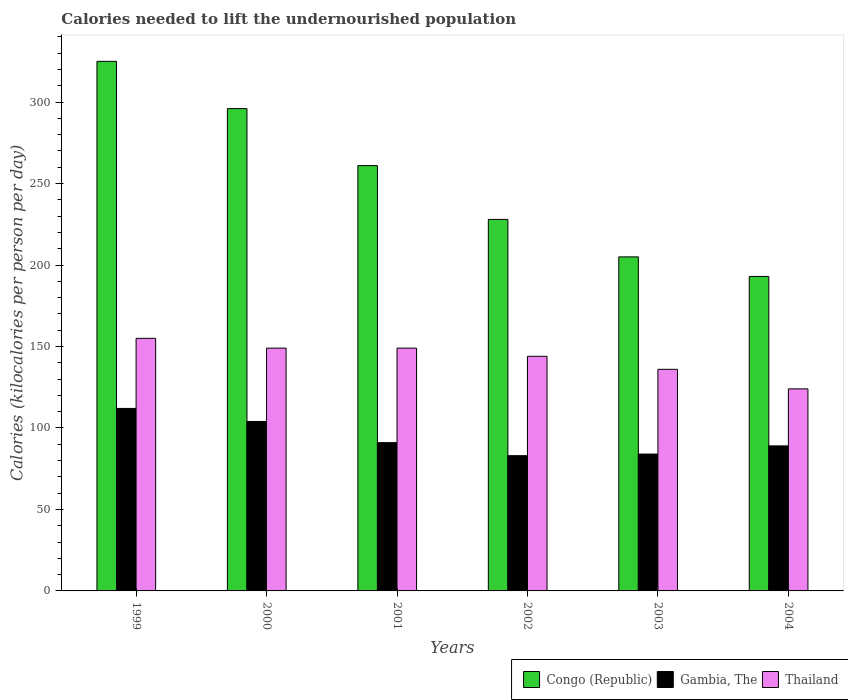How many groups of bars are there?
Make the answer very short. 6. Are the number of bars on each tick of the X-axis equal?
Offer a terse response. Yes. What is the total calories needed to lift the undernourished population in Gambia, The in 2003?
Make the answer very short. 84. Across all years, what is the maximum total calories needed to lift the undernourished population in Congo (Republic)?
Ensure brevity in your answer.  325. Across all years, what is the minimum total calories needed to lift the undernourished population in Congo (Republic)?
Your response must be concise. 193. In which year was the total calories needed to lift the undernourished population in Congo (Republic) maximum?
Offer a terse response. 1999. In which year was the total calories needed to lift the undernourished population in Congo (Republic) minimum?
Offer a terse response. 2004. What is the total total calories needed to lift the undernourished population in Thailand in the graph?
Provide a short and direct response. 857. What is the difference between the total calories needed to lift the undernourished population in Gambia, The in 2000 and that in 2004?
Your response must be concise. 15. What is the difference between the total calories needed to lift the undernourished population in Congo (Republic) in 2000 and the total calories needed to lift the undernourished population in Thailand in 2001?
Provide a short and direct response. 147. What is the average total calories needed to lift the undernourished population in Gambia, The per year?
Offer a terse response. 93.83. In the year 2004, what is the difference between the total calories needed to lift the undernourished population in Thailand and total calories needed to lift the undernourished population in Congo (Republic)?
Offer a terse response. -69. What is the ratio of the total calories needed to lift the undernourished population in Congo (Republic) in 2003 to that in 2004?
Keep it short and to the point. 1.06. Is the total calories needed to lift the undernourished population in Gambia, The in 1999 less than that in 2000?
Your response must be concise. No. Is the difference between the total calories needed to lift the undernourished population in Thailand in 1999 and 2000 greater than the difference between the total calories needed to lift the undernourished population in Congo (Republic) in 1999 and 2000?
Offer a very short reply. No. What is the difference between the highest and the second highest total calories needed to lift the undernourished population in Congo (Republic)?
Provide a short and direct response. 29. What is the difference between the highest and the lowest total calories needed to lift the undernourished population in Congo (Republic)?
Provide a short and direct response. 132. Is the sum of the total calories needed to lift the undernourished population in Congo (Republic) in 1999 and 2004 greater than the maximum total calories needed to lift the undernourished population in Thailand across all years?
Give a very brief answer. Yes. What does the 1st bar from the left in 2001 represents?
Give a very brief answer. Congo (Republic). What does the 2nd bar from the right in 2000 represents?
Keep it short and to the point. Gambia, The. Is it the case that in every year, the sum of the total calories needed to lift the undernourished population in Thailand and total calories needed to lift the undernourished population in Congo (Republic) is greater than the total calories needed to lift the undernourished population in Gambia, The?
Offer a very short reply. Yes. How many bars are there?
Make the answer very short. 18. How many years are there in the graph?
Provide a short and direct response. 6. What is the difference between two consecutive major ticks on the Y-axis?
Give a very brief answer. 50. Does the graph contain any zero values?
Offer a very short reply. No. Does the graph contain grids?
Ensure brevity in your answer.  No. How many legend labels are there?
Offer a terse response. 3. What is the title of the graph?
Your response must be concise. Calories needed to lift the undernourished population. Does "Sao Tome and Principe" appear as one of the legend labels in the graph?
Offer a very short reply. No. What is the label or title of the X-axis?
Your response must be concise. Years. What is the label or title of the Y-axis?
Provide a short and direct response. Calories (kilocalories per person per day). What is the Calories (kilocalories per person per day) in Congo (Republic) in 1999?
Provide a short and direct response. 325. What is the Calories (kilocalories per person per day) in Gambia, The in 1999?
Offer a very short reply. 112. What is the Calories (kilocalories per person per day) of Thailand in 1999?
Make the answer very short. 155. What is the Calories (kilocalories per person per day) in Congo (Republic) in 2000?
Give a very brief answer. 296. What is the Calories (kilocalories per person per day) in Gambia, The in 2000?
Give a very brief answer. 104. What is the Calories (kilocalories per person per day) in Thailand in 2000?
Provide a succinct answer. 149. What is the Calories (kilocalories per person per day) of Congo (Republic) in 2001?
Provide a succinct answer. 261. What is the Calories (kilocalories per person per day) of Gambia, The in 2001?
Give a very brief answer. 91. What is the Calories (kilocalories per person per day) of Thailand in 2001?
Offer a very short reply. 149. What is the Calories (kilocalories per person per day) in Congo (Republic) in 2002?
Provide a succinct answer. 228. What is the Calories (kilocalories per person per day) in Thailand in 2002?
Ensure brevity in your answer.  144. What is the Calories (kilocalories per person per day) in Congo (Republic) in 2003?
Offer a very short reply. 205. What is the Calories (kilocalories per person per day) of Gambia, The in 2003?
Your answer should be very brief. 84. What is the Calories (kilocalories per person per day) in Thailand in 2003?
Make the answer very short. 136. What is the Calories (kilocalories per person per day) of Congo (Republic) in 2004?
Give a very brief answer. 193. What is the Calories (kilocalories per person per day) of Gambia, The in 2004?
Provide a short and direct response. 89. What is the Calories (kilocalories per person per day) of Thailand in 2004?
Your answer should be very brief. 124. Across all years, what is the maximum Calories (kilocalories per person per day) of Congo (Republic)?
Keep it short and to the point. 325. Across all years, what is the maximum Calories (kilocalories per person per day) of Gambia, The?
Provide a succinct answer. 112. Across all years, what is the maximum Calories (kilocalories per person per day) of Thailand?
Keep it short and to the point. 155. Across all years, what is the minimum Calories (kilocalories per person per day) in Congo (Republic)?
Provide a succinct answer. 193. Across all years, what is the minimum Calories (kilocalories per person per day) in Gambia, The?
Offer a terse response. 83. Across all years, what is the minimum Calories (kilocalories per person per day) in Thailand?
Your answer should be compact. 124. What is the total Calories (kilocalories per person per day) of Congo (Republic) in the graph?
Your answer should be compact. 1508. What is the total Calories (kilocalories per person per day) in Gambia, The in the graph?
Make the answer very short. 563. What is the total Calories (kilocalories per person per day) of Thailand in the graph?
Keep it short and to the point. 857. What is the difference between the Calories (kilocalories per person per day) of Gambia, The in 1999 and that in 2000?
Provide a succinct answer. 8. What is the difference between the Calories (kilocalories per person per day) in Gambia, The in 1999 and that in 2001?
Make the answer very short. 21. What is the difference between the Calories (kilocalories per person per day) of Thailand in 1999 and that in 2001?
Ensure brevity in your answer.  6. What is the difference between the Calories (kilocalories per person per day) of Congo (Republic) in 1999 and that in 2002?
Offer a very short reply. 97. What is the difference between the Calories (kilocalories per person per day) in Congo (Republic) in 1999 and that in 2003?
Give a very brief answer. 120. What is the difference between the Calories (kilocalories per person per day) in Congo (Republic) in 1999 and that in 2004?
Ensure brevity in your answer.  132. What is the difference between the Calories (kilocalories per person per day) in Gambia, The in 1999 and that in 2004?
Make the answer very short. 23. What is the difference between the Calories (kilocalories per person per day) in Thailand in 2000 and that in 2002?
Offer a terse response. 5. What is the difference between the Calories (kilocalories per person per day) of Congo (Republic) in 2000 and that in 2003?
Give a very brief answer. 91. What is the difference between the Calories (kilocalories per person per day) of Thailand in 2000 and that in 2003?
Provide a succinct answer. 13. What is the difference between the Calories (kilocalories per person per day) in Congo (Republic) in 2000 and that in 2004?
Your response must be concise. 103. What is the difference between the Calories (kilocalories per person per day) in Gambia, The in 2000 and that in 2004?
Ensure brevity in your answer.  15. What is the difference between the Calories (kilocalories per person per day) in Thailand in 2000 and that in 2004?
Ensure brevity in your answer.  25. What is the difference between the Calories (kilocalories per person per day) in Thailand in 2001 and that in 2002?
Ensure brevity in your answer.  5. What is the difference between the Calories (kilocalories per person per day) of Congo (Republic) in 2001 and that in 2003?
Offer a terse response. 56. What is the difference between the Calories (kilocalories per person per day) of Gambia, The in 2001 and that in 2003?
Offer a terse response. 7. What is the difference between the Calories (kilocalories per person per day) of Thailand in 2001 and that in 2004?
Offer a very short reply. 25. What is the difference between the Calories (kilocalories per person per day) of Congo (Republic) in 2002 and that in 2003?
Ensure brevity in your answer.  23. What is the difference between the Calories (kilocalories per person per day) of Gambia, The in 2002 and that in 2003?
Provide a succinct answer. -1. What is the difference between the Calories (kilocalories per person per day) of Thailand in 2002 and that in 2003?
Provide a succinct answer. 8. What is the difference between the Calories (kilocalories per person per day) of Gambia, The in 2003 and that in 2004?
Your response must be concise. -5. What is the difference between the Calories (kilocalories per person per day) in Thailand in 2003 and that in 2004?
Provide a short and direct response. 12. What is the difference between the Calories (kilocalories per person per day) of Congo (Republic) in 1999 and the Calories (kilocalories per person per day) of Gambia, The in 2000?
Ensure brevity in your answer.  221. What is the difference between the Calories (kilocalories per person per day) in Congo (Republic) in 1999 and the Calories (kilocalories per person per day) in Thailand in 2000?
Provide a succinct answer. 176. What is the difference between the Calories (kilocalories per person per day) in Gambia, The in 1999 and the Calories (kilocalories per person per day) in Thailand in 2000?
Provide a succinct answer. -37. What is the difference between the Calories (kilocalories per person per day) of Congo (Republic) in 1999 and the Calories (kilocalories per person per day) of Gambia, The in 2001?
Ensure brevity in your answer.  234. What is the difference between the Calories (kilocalories per person per day) in Congo (Republic) in 1999 and the Calories (kilocalories per person per day) in Thailand in 2001?
Your answer should be very brief. 176. What is the difference between the Calories (kilocalories per person per day) in Gambia, The in 1999 and the Calories (kilocalories per person per day) in Thailand in 2001?
Ensure brevity in your answer.  -37. What is the difference between the Calories (kilocalories per person per day) of Congo (Republic) in 1999 and the Calories (kilocalories per person per day) of Gambia, The in 2002?
Provide a short and direct response. 242. What is the difference between the Calories (kilocalories per person per day) in Congo (Republic) in 1999 and the Calories (kilocalories per person per day) in Thailand in 2002?
Your answer should be very brief. 181. What is the difference between the Calories (kilocalories per person per day) in Gambia, The in 1999 and the Calories (kilocalories per person per day) in Thailand in 2002?
Offer a terse response. -32. What is the difference between the Calories (kilocalories per person per day) in Congo (Republic) in 1999 and the Calories (kilocalories per person per day) in Gambia, The in 2003?
Your response must be concise. 241. What is the difference between the Calories (kilocalories per person per day) of Congo (Republic) in 1999 and the Calories (kilocalories per person per day) of Thailand in 2003?
Keep it short and to the point. 189. What is the difference between the Calories (kilocalories per person per day) of Gambia, The in 1999 and the Calories (kilocalories per person per day) of Thailand in 2003?
Your response must be concise. -24. What is the difference between the Calories (kilocalories per person per day) in Congo (Republic) in 1999 and the Calories (kilocalories per person per day) in Gambia, The in 2004?
Provide a succinct answer. 236. What is the difference between the Calories (kilocalories per person per day) of Congo (Republic) in 1999 and the Calories (kilocalories per person per day) of Thailand in 2004?
Make the answer very short. 201. What is the difference between the Calories (kilocalories per person per day) in Gambia, The in 1999 and the Calories (kilocalories per person per day) in Thailand in 2004?
Provide a short and direct response. -12. What is the difference between the Calories (kilocalories per person per day) of Congo (Republic) in 2000 and the Calories (kilocalories per person per day) of Gambia, The in 2001?
Keep it short and to the point. 205. What is the difference between the Calories (kilocalories per person per day) in Congo (Republic) in 2000 and the Calories (kilocalories per person per day) in Thailand in 2001?
Make the answer very short. 147. What is the difference between the Calories (kilocalories per person per day) of Gambia, The in 2000 and the Calories (kilocalories per person per day) of Thailand in 2001?
Keep it short and to the point. -45. What is the difference between the Calories (kilocalories per person per day) in Congo (Republic) in 2000 and the Calories (kilocalories per person per day) in Gambia, The in 2002?
Keep it short and to the point. 213. What is the difference between the Calories (kilocalories per person per day) of Congo (Republic) in 2000 and the Calories (kilocalories per person per day) of Thailand in 2002?
Your answer should be compact. 152. What is the difference between the Calories (kilocalories per person per day) in Gambia, The in 2000 and the Calories (kilocalories per person per day) in Thailand in 2002?
Your answer should be very brief. -40. What is the difference between the Calories (kilocalories per person per day) of Congo (Republic) in 2000 and the Calories (kilocalories per person per day) of Gambia, The in 2003?
Offer a very short reply. 212. What is the difference between the Calories (kilocalories per person per day) in Congo (Republic) in 2000 and the Calories (kilocalories per person per day) in Thailand in 2003?
Make the answer very short. 160. What is the difference between the Calories (kilocalories per person per day) of Gambia, The in 2000 and the Calories (kilocalories per person per day) of Thailand in 2003?
Provide a short and direct response. -32. What is the difference between the Calories (kilocalories per person per day) of Congo (Republic) in 2000 and the Calories (kilocalories per person per day) of Gambia, The in 2004?
Make the answer very short. 207. What is the difference between the Calories (kilocalories per person per day) in Congo (Republic) in 2000 and the Calories (kilocalories per person per day) in Thailand in 2004?
Offer a very short reply. 172. What is the difference between the Calories (kilocalories per person per day) of Congo (Republic) in 2001 and the Calories (kilocalories per person per day) of Gambia, The in 2002?
Your answer should be very brief. 178. What is the difference between the Calories (kilocalories per person per day) of Congo (Republic) in 2001 and the Calories (kilocalories per person per day) of Thailand in 2002?
Your response must be concise. 117. What is the difference between the Calories (kilocalories per person per day) of Gambia, The in 2001 and the Calories (kilocalories per person per day) of Thailand in 2002?
Provide a short and direct response. -53. What is the difference between the Calories (kilocalories per person per day) of Congo (Republic) in 2001 and the Calories (kilocalories per person per day) of Gambia, The in 2003?
Ensure brevity in your answer.  177. What is the difference between the Calories (kilocalories per person per day) in Congo (Republic) in 2001 and the Calories (kilocalories per person per day) in Thailand in 2003?
Provide a short and direct response. 125. What is the difference between the Calories (kilocalories per person per day) of Gambia, The in 2001 and the Calories (kilocalories per person per day) of Thailand in 2003?
Ensure brevity in your answer.  -45. What is the difference between the Calories (kilocalories per person per day) in Congo (Republic) in 2001 and the Calories (kilocalories per person per day) in Gambia, The in 2004?
Offer a very short reply. 172. What is the difference between the Calories (kilocalories per person per day) of Congo (Republic) in 2001 and the Calories (kilocalories per person per day) of Thailand in 2004?
Your response must be concise. 137. What is the difference between the Calories (kilocalories per person per day) of Gambia, The in 2001 and the Calories (kilocalories per person per day) of Thailand in 2004?
Provide a short and direct response. -33. What is the difference between the Calories (kilocalories per person per day) in Congo (Republic) in 2002 and the Calories (kilocalories per person per day) in Gambia, The in 2003?
Your answer should be compact. 144. What is the difference between the Calories (kilocalories per person per day) in Congo (Republic) in 2002 and the Calories (kilocalories per person per day) in Thailand in 2003?
Your answer should be very brief. 92. What is the difference between the Calories (kilocalories per person per day) in Gambia, The in 2002 and the Calories (kilocalories per person per day) in Thailand in 2003?
Keep it short and to the point. -53. What is the difference between the Calories (kilocalories per person per day) in Congo (Republic) in 2002 and the Calories (kilocalories per person per day) in Gambia, The in 2004?
Your answer should be very brief. 139. What is the difference between the Calories (kilocalories per person per day) of Congo (Republic) in 2002 and the Calories (kilocalories per person per day) of Thailand in 2004?
Give a very brief answer. 104. What is the difference between the Calories (kilocalories per person per day) in Gambia, The in 2002 and the Calories (kilocalories per person per day) in Thailand in 2004?
Make the answer very short. -41. What is the difference between the Calories (kilocalories per person per day) of Congo (Republic) in 2003 and the Calories (kilocalories per person per day) of Gambia, The in 2004?
Your answer should be compact. 116. What is the difference between the Calories (kilocalories per person per day) in Congo (Republic) in 2003 and the Calories (kilocalories per person per day) in Thailand in 2004?
Make the answer very short. 81. What is the difference between the Calories (kilocalories per person per day) in Gambia, The in 2003 and the Calories (kilocalories per person per day) in Thailand in 2004?
Provide a short and direct response. -40. What is the average Calories (kilocalories per person per day) in Congo (Republic) per year?
Provide a short and direct response. 251.33. What is the average Calories (kilocalories per person per day) of Gambia, The per year?
Keep it short and to the point. 93.83. What is the average Calories (kilocalories per person per day) in Thailand per year?
Your answer should be very brief. 142.83. In the year 1999, what is the difference between the Calories (kilocalories per person per day) in Congo (Republic) and Calories (kilocalories per person per day) in Gambia, The?
Your answer should be compact. 213. In the year 1999, what is the difference between the Calories (kilocalories per person per day) in Congo (Republic) and Calories (kilocalories per person per day) in Thailand?
Offer a very short reply. 170. In the year 1999, what is the difference between the Calories (kilocalories per person per day) of Gambia, The and Calories (kilocalories per person per day) of Thailand?
Make the answer very short. -43. In the year 2000, what is the difference between the Calories (kilocalories per person per day) of Congo (Republic) and Calories (kilocalories per person per day) of Gambia, The?
Your answer should be very brief. 192. In the year 2000, what is the difference between the Calories (kilocalories per person per day) of Congo (Republic) and Calories (kilocalories per person per day) of Thailand?
Provide a short and direct response. 147. In the year 2000, what is the difference between the Calories (kilocalories per person per day) in Gambia, The and Calories (kilocalories per person per day) in Thailand?
Your answer should be very brief. -45. In the year 2001, what is the difference between the Calories (kilocalories per person per day) in Congo (Republic) and Calories (kilocalories per person per day) in Gambia, The?
Make the answer very short. 170. In the year 2001, what is the difference between the Calories (kilocalories per person per day) of Congo (Republic) and Calories (kilocalories per person per day) of Thailand?
Give a very brief answer. 112. In the year 2001, what is the difference between the Calories (kilocalories per person per day) of Gambia, The and Calories (kilocalories per person per day) of Thailand?
Your answer should be very brief. -58. In the year 2002, what is the difference between the Calories (kilocalories per person per day) in Congo (Republic) and Calories (kilocalories per person per day) in Gambia, The?
Ensure brevity in your answer.  145. In the year 2002, what is the difference between the Calories (kilocalories per person per day) of Congo (Republic) and Calories (kilocalories per person per day) of Thailand?
Your answer should be very brief. 84. In the year 2002, what is the difference between the Calories (kilocalories per person per day) in Gambia, The and Calories (kilocalories per person per day) in Thailand?
Your answer should be very brief. -61. In the year 2003, what is the difference between the Calories (kilocalories per person per day) in Congo (Republic) and Calories (kilocalories per person per day) in Gambia, The?
Give a very brief answer. 121. In the year 2003, what is the difference between the Calories (kilocalories per person per day) of Congo (Republic) and Calories (kilocalories per person per day) of Thailand?
Your answer should be very brief. 69. In the year 2003, what is the difference between the Calories (kilocalories per person per day) in Gambia, The and Calories (kilocalories per person per day) in Thailand?
Provide a succinct answer. -52. In the year 2004, what is the difference between the Calories (kilocalories per person per day) in Congo (Republic) and Calories (kilocalories per person per day) in Gambia, The?
Give a very brief answer. 104. In the year 2004, what is the difference between the Calories (kilocalories per person per day) in Congo (Republic) and Calories (kilocalories per person per day) in Thailand?
Keep it short and to the point. 69. In the year 2004, what is the difference between the Calories (kilocalories per person per day) of Gambia, The and Calories (kilocalories per person per day) of Thailand?
Provide a short and direct response. -35. What is the ratio of the Calories (kilocalories per person per day) in Congo (Republic) in 1999 to that in 2000?
Give a very brief answer. 1.1. What is the ratio of the Calories (kilocalories per person per day) of Thailand in 1999 to that in 2000?
Your answer should be compact. 1.04. What is the ratio of the Calories (kilocalories per person per day) of Congo (Republic) in 1999 to that in 2001?
Offer a very short reply. 1.25. What is the ratio of the Calories (kilocalories per person per day) of Gambia, The in 1999 to that in 2001?
Keep it short and to the point. 1.23. What is the ratio of the Calories (kilocalories per person per day) of Thailand in 1999 to that in 2001?
Offer a terse response. 1.04. What is the ratio of the Calories (kilocalories per person per day) of Congo (Republic) in 1999 to that in 2002?
Offer a very short reply. 1.43. What is the ratio of the Calories (kilocalories per person per day) in Gambia, The in 1999 to that in 2002?
Your response must be concise. 1.35. What is the ratio of the Calories (kilocalories per person per day) of Thailand in 1999 to that in 2002?
Provide a short and direct response. 1.08. What is the ratio of the Calories (kilocalories per person per day) of Congo (Republic) in 1999 to that in 2003?
Make the answer very short. 1.59. What is the ratio of the Calories (kilocalories per person per day) in Gambia, The in 1999 to that in 2003?
Provide a succinct answer. 1.33. What is the ratio of the Calories (kilocalories per person per day) in Thailand in 1999 to that in 2003?
Your response must be concise. 1.14. What is the ratio of the Calories (kilocalories per person per day) in Congo (Republic) in 1999 to that in 2004?
Offer a very short reply. 1.68. What is the ratio of the Calories (kilocalories per person per day) in Gambia, The in 1999 to that in 2004?
Provide a short and direct response. 1.26. What is the ratio of the Calories (kilocalories per person per day) in Congo (Republic) in 2000 to that in 2001?
Your answer should be very brief. 1.13. What is the ratio of the Calories (kilocalories per person per day) in Congo (Republic) in 2000 to that in 2002?
Your answer should be very brief. 1.3. What is the ratio of the Calories (kilocalories per person per day) in Gambia, The in 2000 to that in 2002?
Offer a terse response. 1.25. What is the ratio of the Calories (kilocalories per person per day) of Thailand in 2000 to that in 2002?
Provide a succinct answer. 1.03. What is the ratio of the Calories (kilocalories per person per day) in Congo (Republic) in 2000 to that in 2003?
Offer a very short reply. 1.44. What is the ratio of the Calories (kilocalories per person per day) in Gambia, The in 2000 to that in 2003?
Your answer should be compact. 1.24. What is the ratio of the Calories (kilocalories per person per day) of Thailand in 2000 to that in 2003?
Give a very brief answer. 1.1. What is the ratio of the Calories (kilocalories per person per day) of Congo (Republic) in 2000 to that in 2004?
Ensure brevity in your answer.  1.53. What is the ratio of the Calories (kilocalories per person per day) in Gambia, The in 2000 to that in 2004?
Your answer should be compact. 1.17. What is the ratio of the Calories (kilocalories per person per day) in Thailand in 2000 to that in 2004?
Your answer should be compact. 1.2. What is the ratio of the Calories (kilocalories per person per day) of Congo (Republic) in 2001 to that in 2002?
Your answer should be very brief. 1.14. What is the ratio of the Calories (kilocalories per person per day) in Gambia, The in 2001 to that in 2002?
Provide a succinct answer. 1.1. What is the ratio of the Calories (kilocalories per person per day) of Thailand in 2001 to that in 2002?
Your answer should be compact. 1.03. What is the ratio of the Calories (kilocalories per person per day) in Congo (Republic) in 2001 to that in 2003?
Make the answer very short. 1.27. What is the ratio of the Calories (kilocalories per person per day) in Thailand in 2001 to that in 2003?
Offer a very short reply. 1.1. What is the ratio of the Calories (kilocalories per person per day) in Congo (Republic) in 2001 to that in 2004?
Your answer should be compact. 1.35. What is the ratio of the Calories (kilocalories per person per day) in Gambia, The in 2001 to that in 2004?
Ensure brevity in your answer.  1.02. What is the ratio of the Calories (kilocalories per person per day) of Thailand in 2001 to that in 2004?
Keep it short and to the point. 1.2. What is the ratio of the Calories (kilocalories per person per day) of Congo (Republic) in 2002 to that in 2003?
Your response must be concise. 1.11. What is the ratio of the Calories (kilocalories per person per day) in Thailand in 2002 to that in 2003?
Your response must be concise. 1.06. What is the ratio of the Calories (kilocalories per person per day) of Congo (Republic) in 2002 to that in 2004?
Give a very brief answer. 1.18. What is the ratio of the Calories (kilocalories per person per day) of Gambia, The in 2002 to that in 2004?
Offer a terse response. 0.93. What is the ratio of the Calories (kilocalories per person per day) in Thailand in 2002 to that in 2004?
Provide a short and direct response. 1.16. What is the ratio of the Calories (kilocalories per person per day) in Congo (Republic) in 2003 to that in 2004?
Make the answer very short. 1.06. What is the ratio of the Calories (kilocalories per person per day) of Gambia, The in 2003 to that in 2004?
Offer a terse response. 0.94. What is the ratio of the Calories (kilocalories per person per day) in Thailand in 2003 to that in 2004?
Provide a short and direct response. 1.1. What is the difference between the highest and the second highest Calories (kilocalories per person per day) in Gambia, The?
Your answer should be compact. 8. What is the difference between the highest and the second highest Calories (kilocalories per person per day) of Thailand?
Offer a terse response. 6. What is the difference between the highest and the lowest Calories (kilocalories per person per day) of Congo (Republic)?
Keep it short and to the point. 132. What is the difference between the highest and the lowest Calories (kilocalories per person per day) of Gambia, The?
Make the answer very short. 29. What is the difference between the highest and the lowest Calories (kilocalories per person per day) in Thailand?
Keep it short and to the point. 31. 